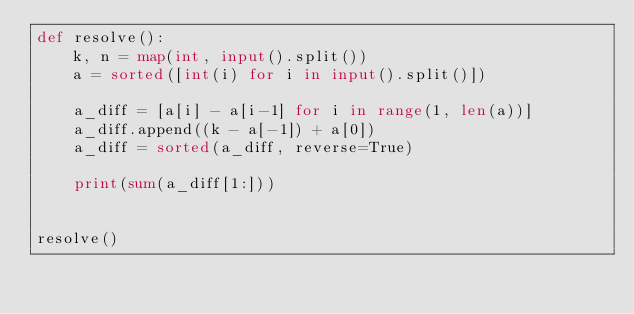<code> <loc_0><loc_0><loc_500><loc_500><_Python_>def resolve():
    k, n = map(int, input().split())
    a = sorted([int(i) for i in input().split()])

    a_diff = [a[i] - a[i-1] for i in range(1, len(a))]
    a_diff.append((k - a[-1]) + a[0])
    a_diff = sorted(a_diff, reverse=True)

    print(sum(a_diff[1:]))


resolve()</code> 